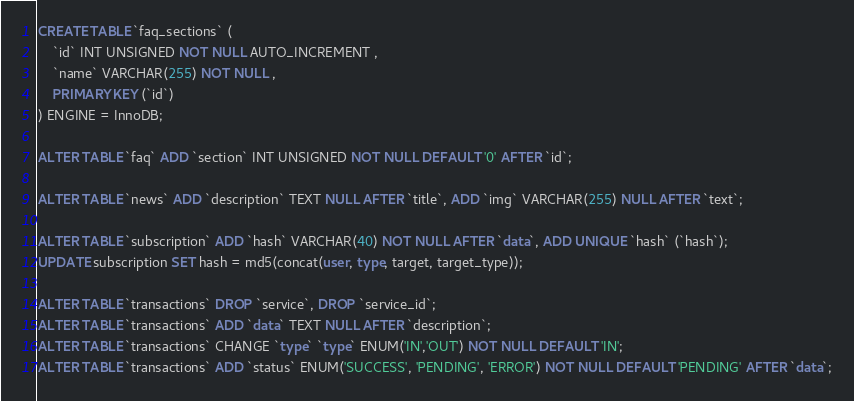Convert code to text. <code><loc_0><loc_0><loc_500><loc_500><_SQL_>CREATE TABLE `faq_sections` ( 
	`id` INT UNSIGNED NOT NULL AUTO_INCREMENT , 
	`name` VARCHAR(255) NOT NULL , 
	PRIMARY KEY (`id`)
) ENGINE = InnoDB;

ALTER TABLE `faq` ADD `section` INT UNSIGNED NOT NULL DEFAULT '0' AFTER `id`;

ALTER TABLE `news` ADD `description` TEXT NULL AFTER `title`, ADD `img` VARCHAR(255) NULL AFTER `text`;

ALTER TABLE `subscription` ADD `hash` VARCHAR(40) NOT NULL AFTER `data`, ADD UNIQUE `hash` (`hash`);
UPDATE subscription SET hash = md5(concat(user, type, target, target_type));

ALTER TABLE `transactions` DROP `service`, DROP `service_id`;
ALTER TABLE `transactions` ADD `data` TEXT NULL AFTER `description`;
ALTER TABLE `transactions` CHANGE `type` `type` ENUM('IN','OUT') NOT NULL DEFAULT 'IN';
ALTER TABLE `transactions` ADD `status` ENUM('SUCCESS', 'PENDING', 'ERROR') NOT NULL DEFAULT 'PENDING' AFTER `data`;</code> 